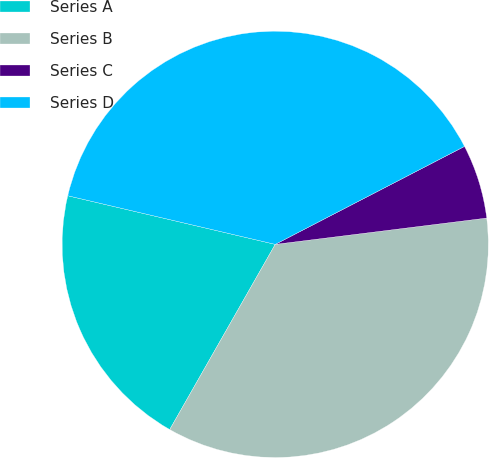<chart> <loc_0><loc_0><loc_500><loc_500><pie_chart><fcel>Series A<fcel>Series B<fcel>Series C<fcel>Series D<nl><fcel>20.42%<fcel>35.21%<fcel>5.63%<fcel>38.73%<nl></chart> 